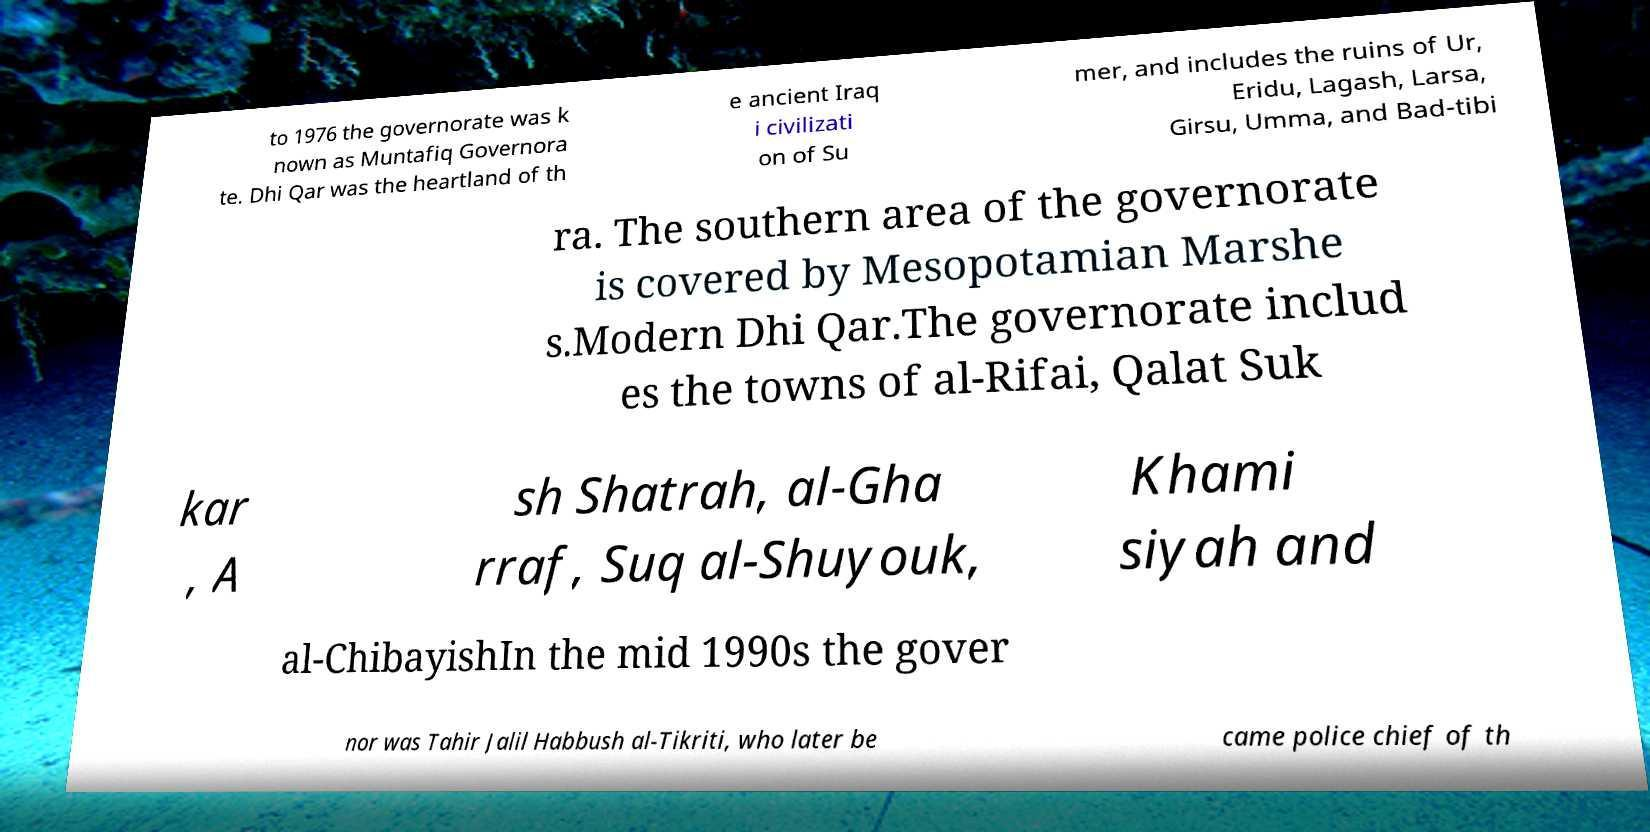For documentation purposes, I need the text within this image transcribed. Could you provide that? to 1976 the governorate was k nown as Muntafiq Governora te. Dhi Qar was the heartland of th e ancient Iraq i civilizati on of Su mer, and includes the ruins of Ur, Eridu, Lagash, Larsa, Girsu, Umma, and Bad-tibi ra. The southern area of the governorate is covered by Mesopotamian Marshe s.Modern Dhi Qar.The governorate includ es the towns of al-Rifai, Qalat Suk kar , A sh Shatrah, al-Gha rraf, Suq al-Shuyouk, Khami siyah and al-ChibayishIn the mid 1990s the gover nor was Tahir Jalil Habbush al-Tikriti, who later be came police chief of th 